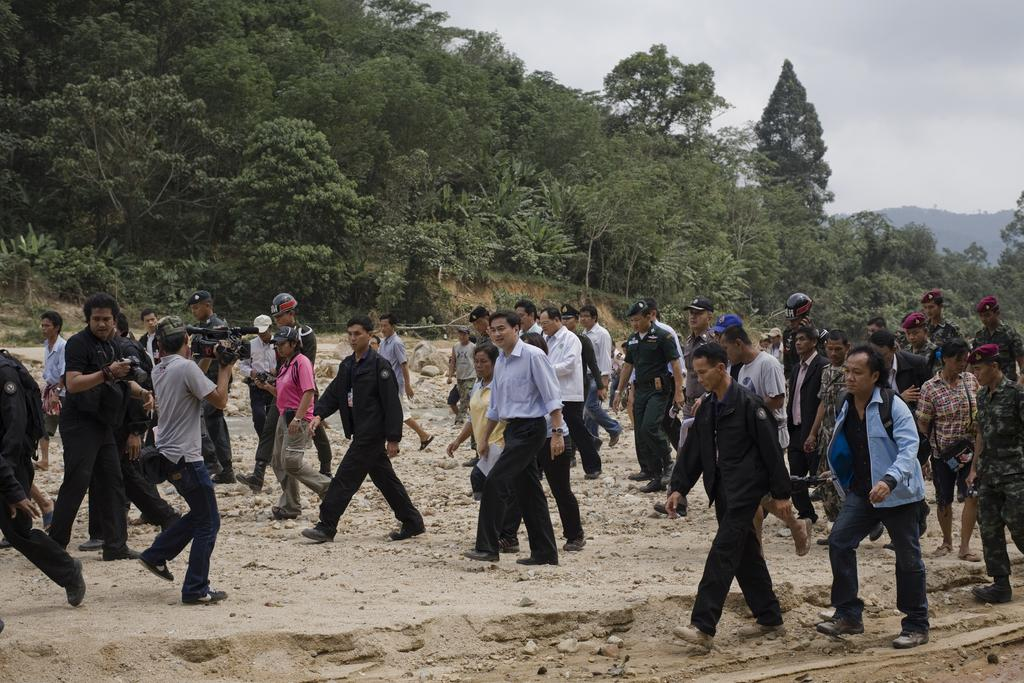What can be seen on the surface in the image? There are people on the surface in the image. What are some people doing in the image? Some people are holding cameras. What type of natural environment is visible in the image? There are trees visible in the image. What is visible in the sky in the image? Clouds are present in the sky. How many ants can be seen crawling on the library in the image? There are no ants or libraries present in the image. What type of boys are visible in the image? There is no mention of boys in the provided facts, so we cannot determine if any are visible in the image. 